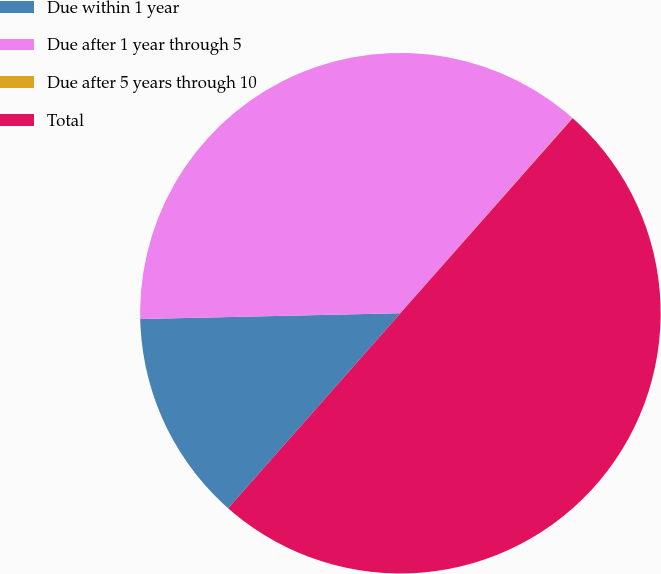Convert chart to OTSL. <chart><loc_0><loc_0><loc_500><loc_500><pie_chart><fcel>Due within 1 year<fcel>Due after 1 year through 5<fcel>Due after 5 years through 10<fcel>Total<nl><fcel>13.13%<fcel>36.84%<fcel>0.03%<fcel>50.0%<nl></chart> 